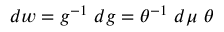Convert formula to latex. <formula><loc_0><loc_0><loc_500><loc_500>d w = g ^ { - 1 } d g = \theta ^ { - 1 } d \mu \theta</formula> 